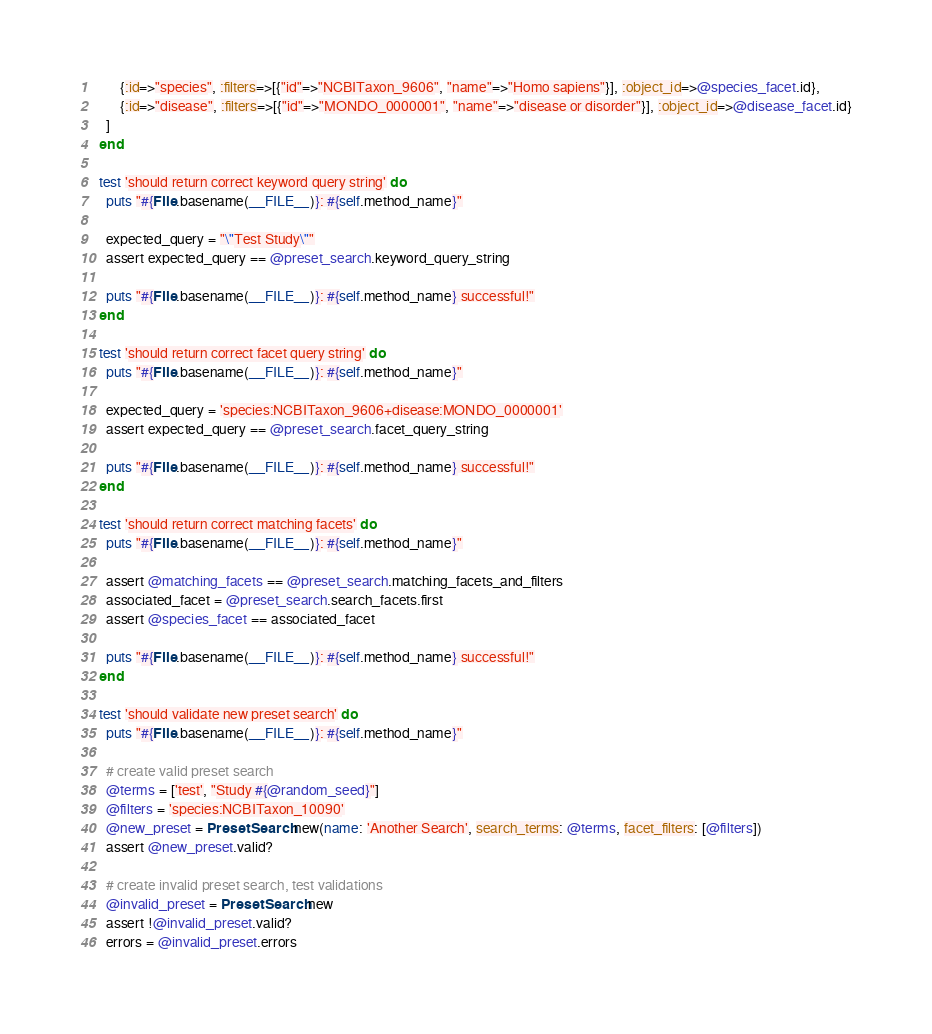Convert code to text. <code><loc_0><loc_0><loc_500><loc_500><_Ruby_>        {:id=>"species", :filters=>[{"id"=>"NCBITaxon_9606", "name"=>"Homo sapiens"}], :object_id=>@species_facet.id},
        {:id=>"disease", :filters=>[{"id"=>"MONDO_0000001", "name"=>"disease or disorder"}], :object_id=>@disease_facet.id}
    ]
  end

  test 'should return correct keyword query string' do
    puts "#{File.basename(__FILE__)}: #{self.method_name}"

    expected_query = "\"Test Study\""
    assert expected_query == @preset_search.keyword_query_string

    puts "#{File.basename(__FILE__)}: #{self.method_name} successful!"
  end

  test 'should return correct facet query string' do
    puts "#{File.basename(__FILE__)}: #{self.method_name}"

    expected_query = 'species:NCBITaxon_9606+disease:MONDO_0000001'
    assert expected_query == @preset_search.facet_query_string

    puts "#{File.basename(__FILE__)}: #{self.method_name} successful!"
  end

  test 'should return correct matching facets' do
    puts "#{File.basename(__FILE__)}: #{self.method_name}"

    assert @matching_facets == @preset_search.matching_facets_and_filters
    associated_facet = @preset_search.search_facets.first
    assert @species_facet == associated_facet

    puts "#{File.basename(__FILE__)}: #{self.method_name} successful!"
  end

  test 'should validate new preset search' do
    puts "#{File.basename(__FILE__)}: #{self.method_name}"

    # create valid preset search
    @terms = ['test', "Study #{@random_seed}"]
    @filters = 'species:NCBITaxon_10090'
    @new_preset = PresetSearch.new(name: 'Another Search', search_terms: @terms, facet_filters: [@filters])
    assert @new_preset.valid?

    # create invalid preset search, test validations
    @invalid_preset = PresetSearch.new
    assert !@invalid_preset.valid?
    errors = @invalid_preset.errors</code> 